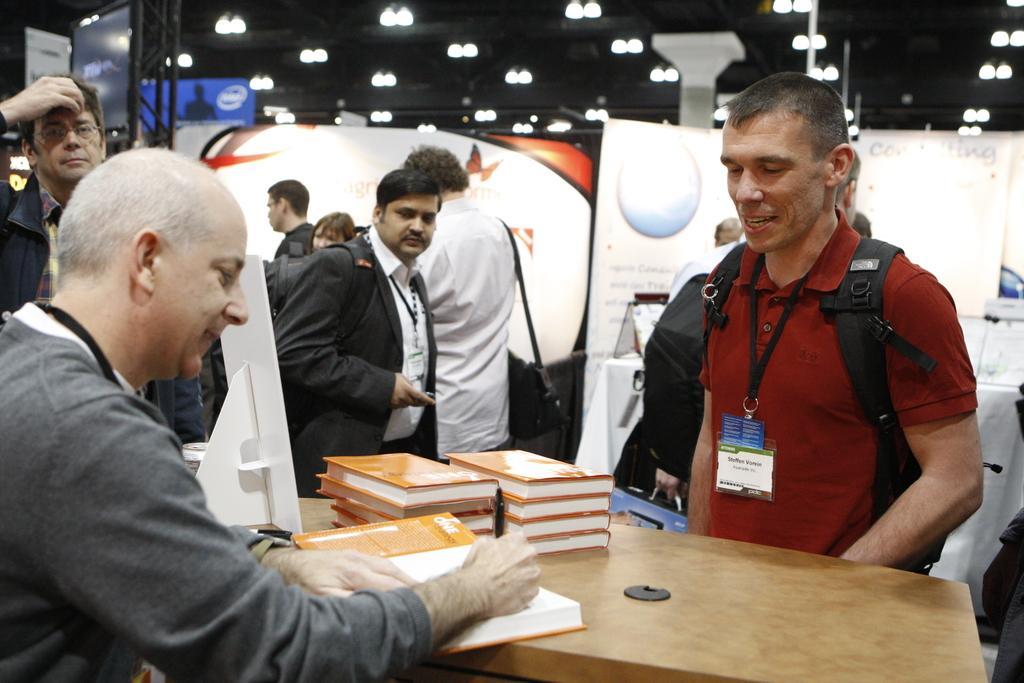Could you give a brief overview of what you see in this image? In this image I can see there are few persons standing and wearing an Id card. And one person is sitting in front of the table. On the table there are books and the person is writing on the book with pen. And at the back there are banners and stand. At the top there is a ceiling with lights. And there are some objects. 